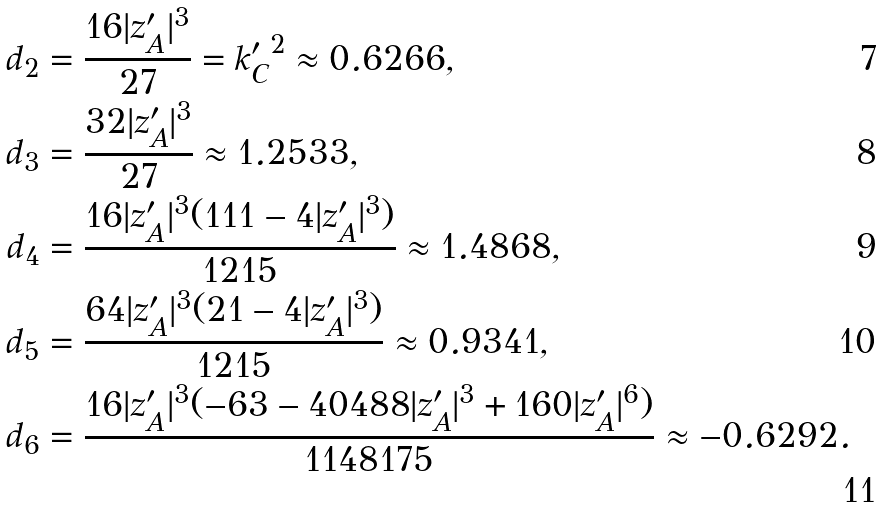Convert formula to latex. <formula><loc_0><loc_0><loc_500><loc_500>d _ { 2 } & = \frac { 1 6 | z ^ { \prime } _ { A } | ^ { 3 } } { 2 7 } = { k ^ { \prime } _ { C } } ^ { 2 } \approx 0 . 6 2 6 6 , \\ d _ { 3 } & = \frac { 3 2 | z ^ { \prime } _ { A } | ^ { 3 } } { 2 7 } \approx 1 . 2 5 3 3 , \\ d _ { 4 } & = \frac { 1 6 | z ^ { \prime } _ { A } | ^ { 3 } ( 1 1 1 - 4 | z ^ { \prime } _ { A } | ^ { 3 } ) } { 1 2 1 5 } \approx 1 . 4 8 6 8 , \\ d _ { 5 } & = \frac { 6 4 | z ^ { \prime } _ { A } | ^ { 3 } ( 2 1 - 4 | z ^ { \prime } _ { A } | ^ { 3 } ) } { 1 2 1 5 } \approx 0 . 9 3 4 1 , \\ d _ { 6 } & = \frac { 1 6 | z ^ { \prime } _ { A } | ^ { 3 } ( - 6 3 - 4 0 4 8 8 | z ^ { \prime } _ { A } | ^ { 3 } + 1 6 0 | z ^ { \prime } _ { A } | ^ { 6 } ) } { 1 1 4 8 1 7 5 } \approx - 0 . 6 2 9 2 .</formula> 